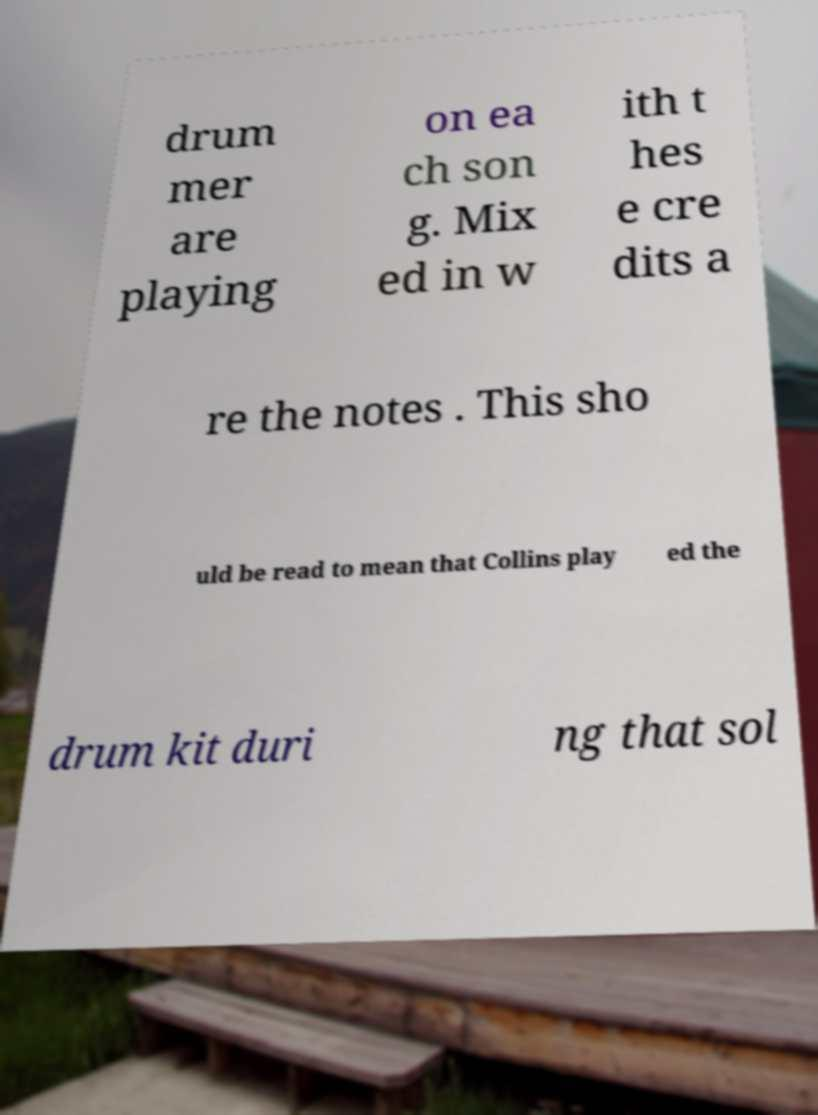I need the written content from this picture converted into text. Can you do that? drum mer are playing on ea ch son g. Mix ed in w ith t hes e cre dits a re the notes . This sho uld be read to mean that Collins play ed the drum kit duri ng that sol 